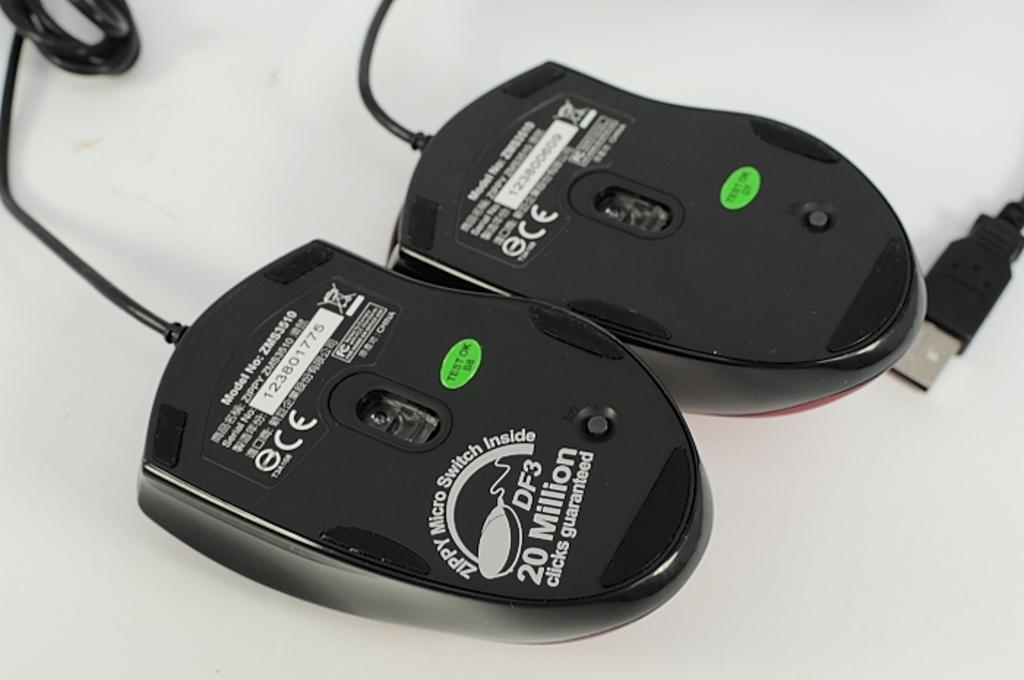Provide a one-sentence caption for the provided image. Durable computer mouse with 20 million clicks guaranteed. 